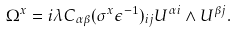Convert formula to latex. <formula><loc_0><loc_0><loc_500><loc_500>\Omega ^ { x } = i \lambda C _ { \alpha \beta } ( \sigma ^ { x } \epsilon ^ { - 1 } ) _ { i j } U ^ { \alpha i } \wedge U ^ { \beta j } .</formula> 